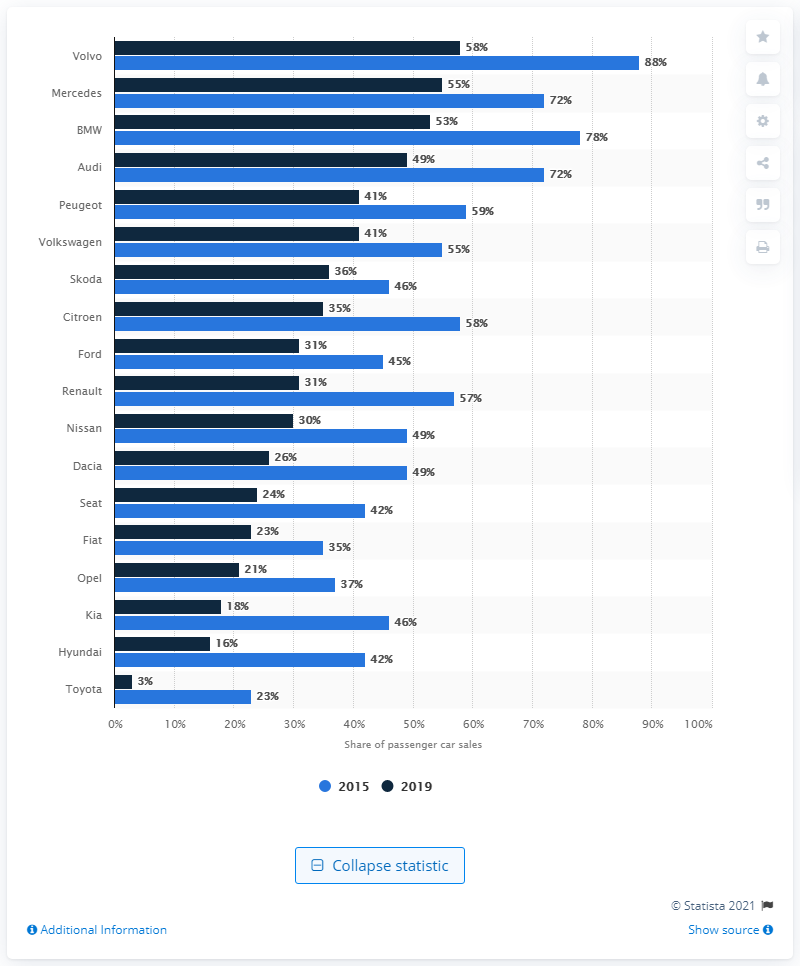Identify some key points in this picture. In 2019, Volvo had the largest share of diesel-fueled passenger cars in Europe. 